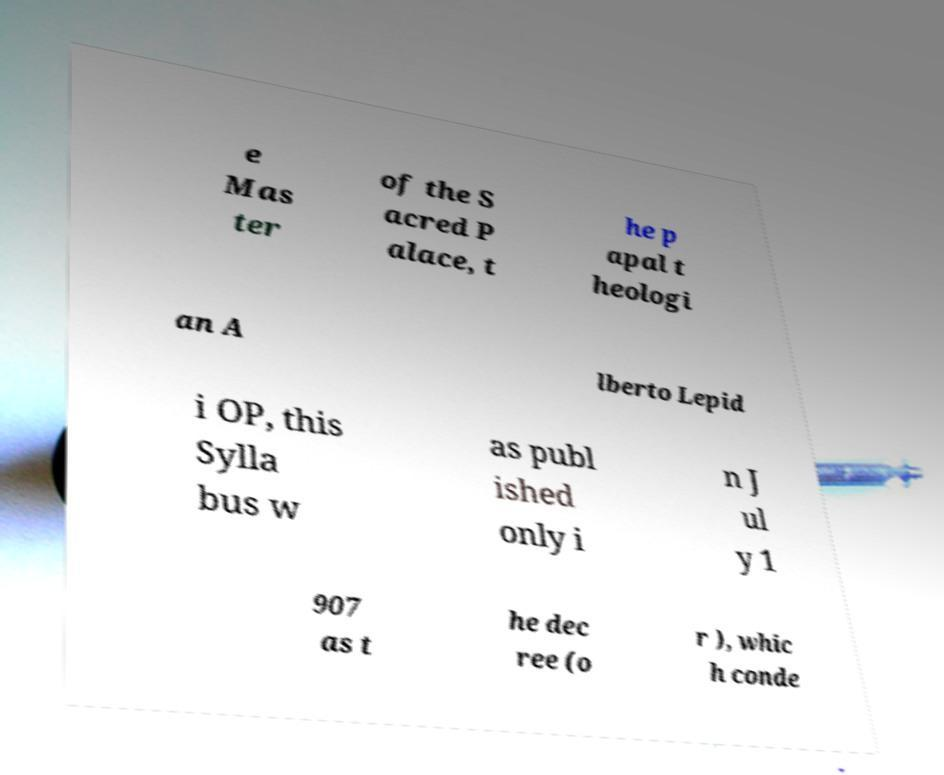There's text embedded in this image that I need extracted. Can you transcribe it verbatim? e Mas ter of the S acred P alace, t he p apal t heologi an A lberto Lepid i OP, this Sylla bus w as publ ished only i n J ul y 1 907 as t he dec ree (o r ), whic h conde 